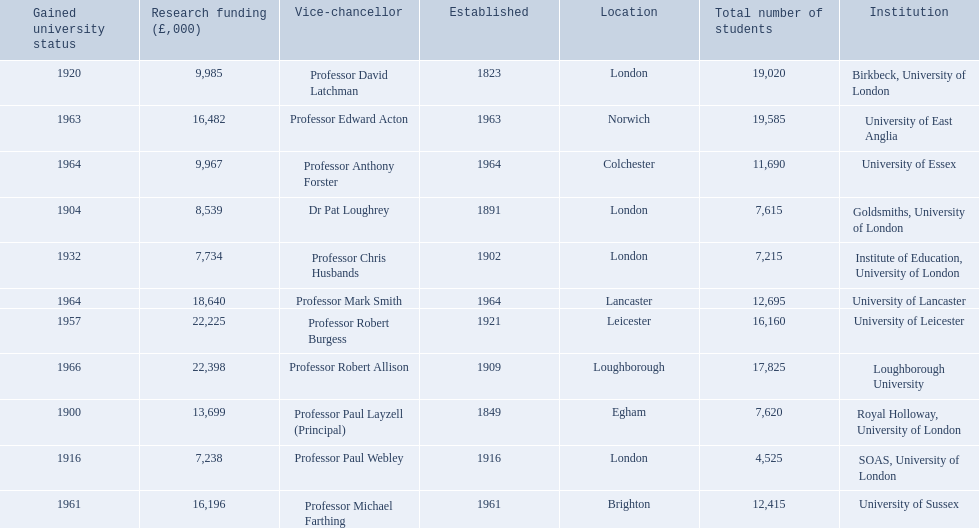What are the institutions in the 1994 group? Birkbeck, University of London, University of East Anglia, University of Essex, Goldsmiths, University of London, Institute of Education, University of London, University of Lancaster, University of Leicester, Loughborough University, Royal Holloway, University of London, SOAS, University of London, University of Sussex. Which of these was made a university most recently? Loughborough University. 